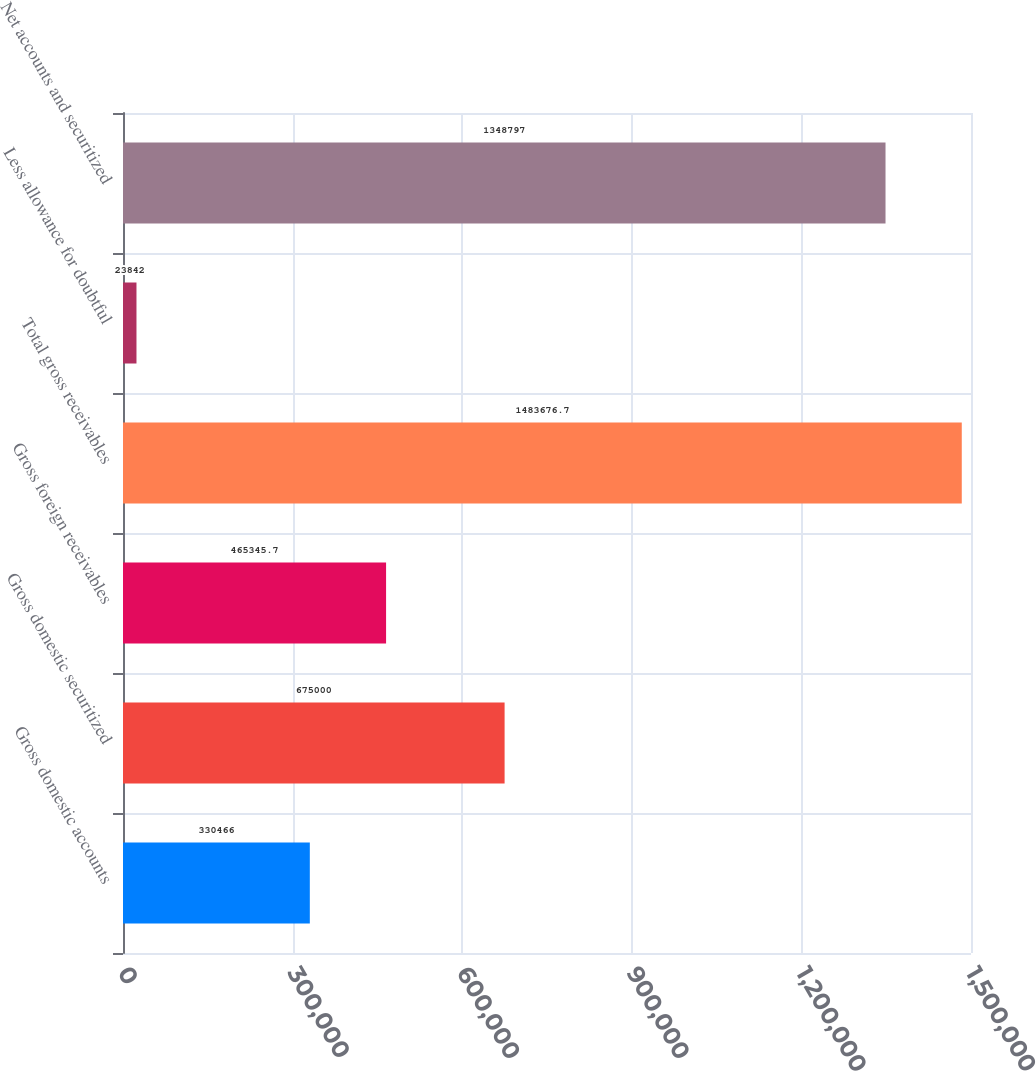<chart> <loc_0><loc_0><loc_500><loc_500><bar_chart><fcel>Gross domestic accounts<fcel>Gross domestic securitized<fcel>Gross foreign receivables<fcel>Total gross receivables<fcel>Less allowance for doubtful<fcel>Net accounts and securitized<nl><fcel>330466<fcel>675000<fcel>465346<fcel>1.48368e+06<fcel>23842<fcel>1.3488e+06<nl></chart> 